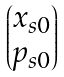Convert formula to latex. <formula><loc_0><loc_0><loc_500><loc_500>\begin{pmatrix} x _ { s 0 } \\ p _ { s 0 } \end{pmatrix}</formula> 